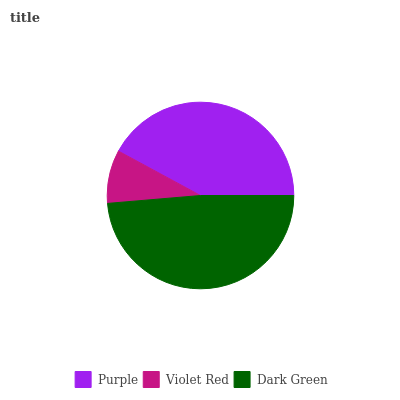Is Violet Red the minimum?
Answer yes or no. Yes. Is Dark Green the maximum?
Answer yes or no. Yes. Is Dark Green the minimum?
Answer yes or no. No. Is Violet Red the maximum?
Answer yes or no. No. Is Dark Green greater than Violet Red?
Answer yes or no. Yes. Is Violet Red less than Dark Green?
Answer yes or no. Yes. Is Violet Red greater than Dark Green?
Answer yes or no. No. Is Dark Green less than Violet Red?
Answer yes or no. No. Is Purple the high median?
Answer yes or no. Yes. Is Purple the low median?
Answer yes or no. Yes. Is Dark Green the high median?
Answer yes or no. No. Is Dark Green the low median?
Answer yes or no. No. 